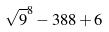Convert formula to latex. <formula><loc_0><loc_0><loc_500><loc_500>\sqrt { 9 } ^ { 8 } - 3 8 8 + 6</formula> 